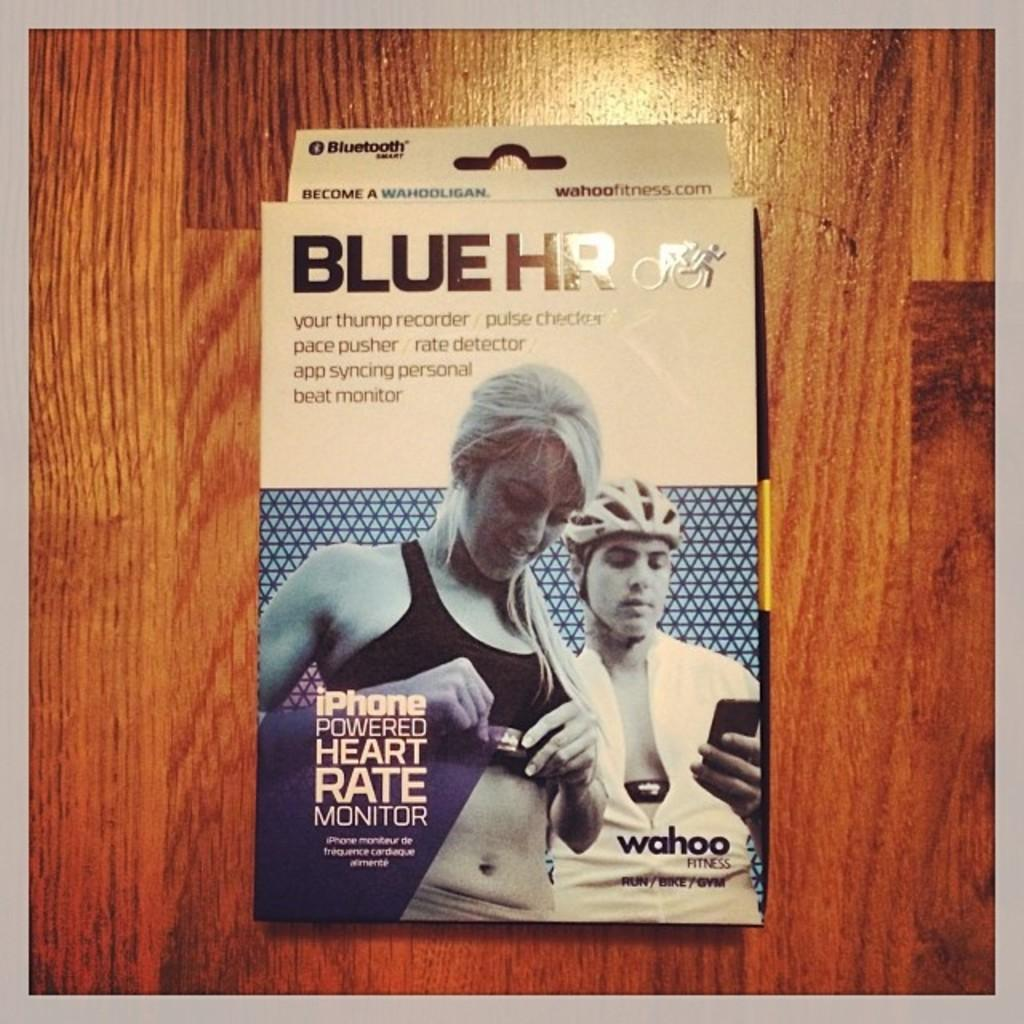<image>
Offer a succinct explanation of the picture presented. A box that says Blue HR on it features two people. 